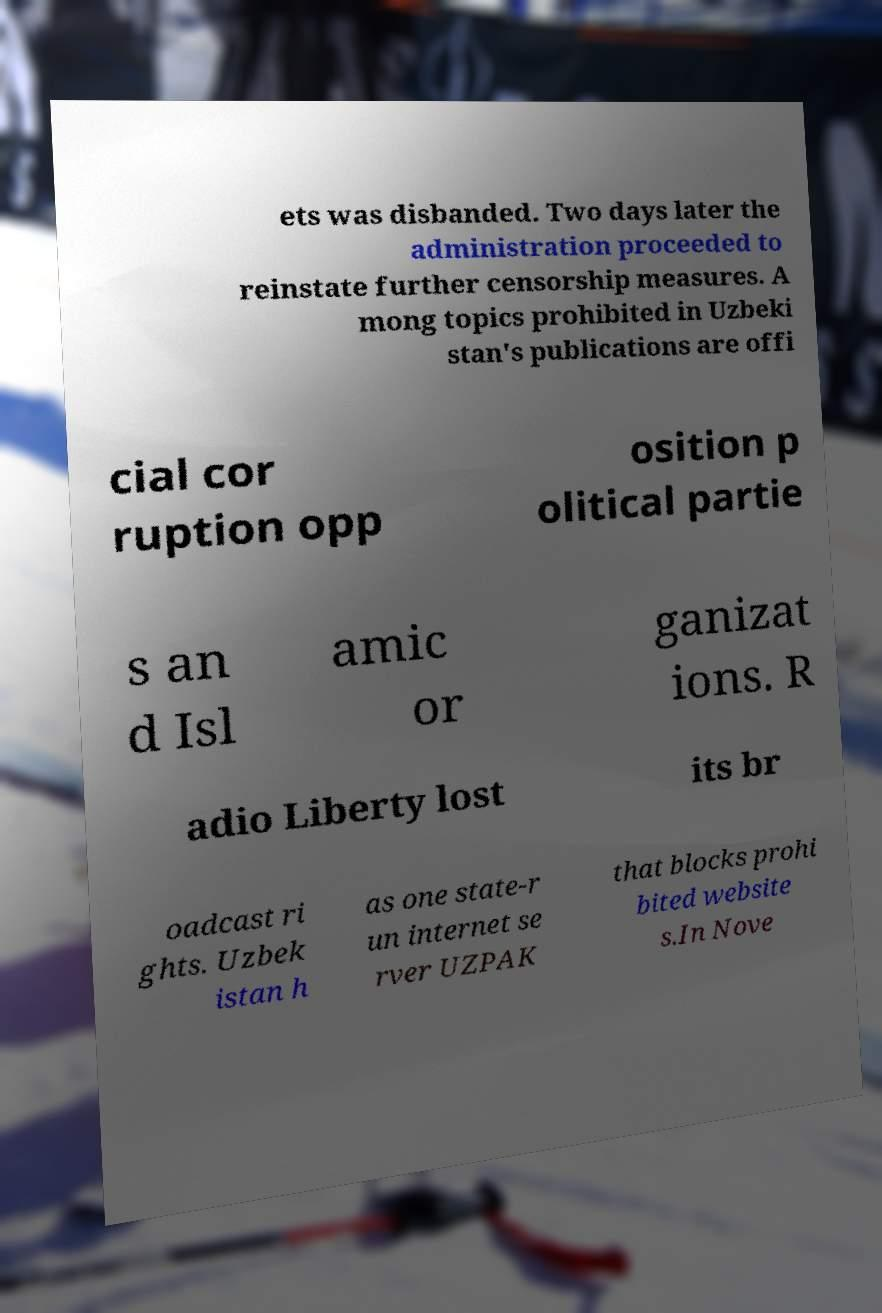Could you assist in decoding the text presented in this image and type it out clearly? ets was disbanded. Two days later the administration proceeded to reinstate further censorship measures. A mong topics prohibited in Uzbeki stan's publications are offi cial cor ruption opp osition p olitical partie s an d Isl amic or ganizat ions. R adio Liberty lost its br oadcast ri ghts. Uzbek istan h as one state-r un internet se rver UZPAK that blocks prohi bited website s.In Nove 